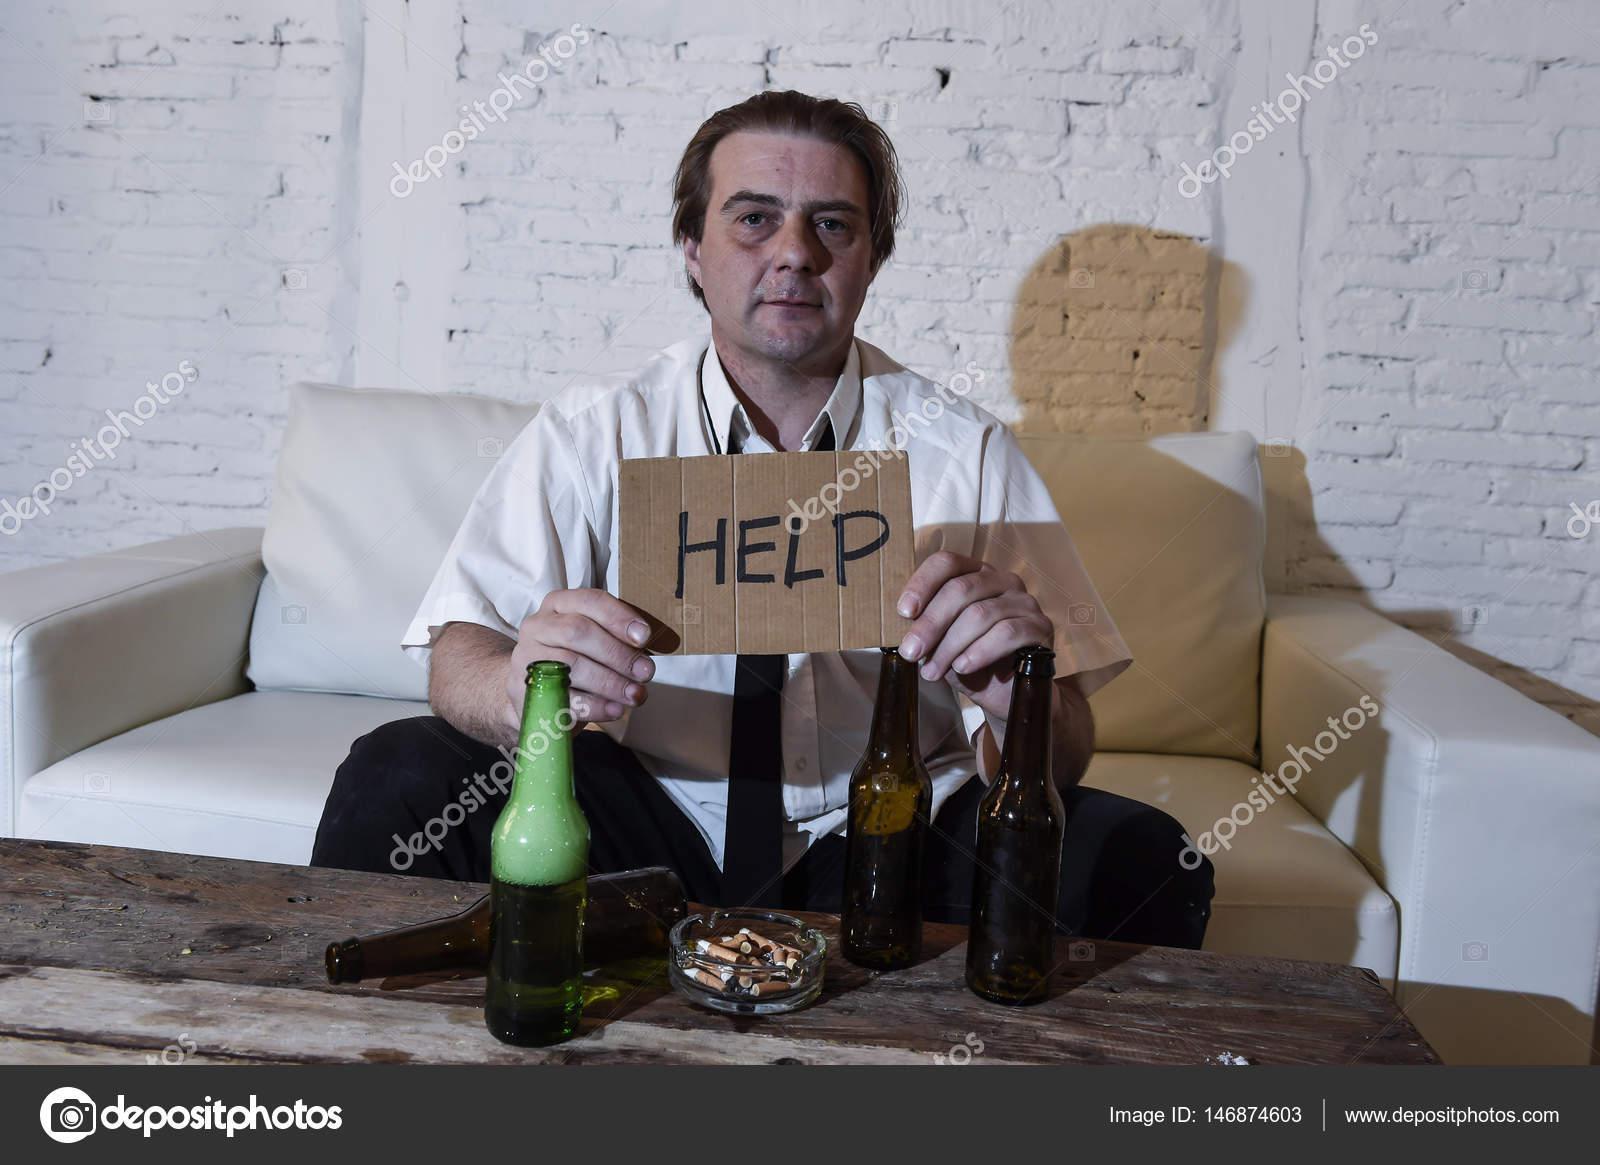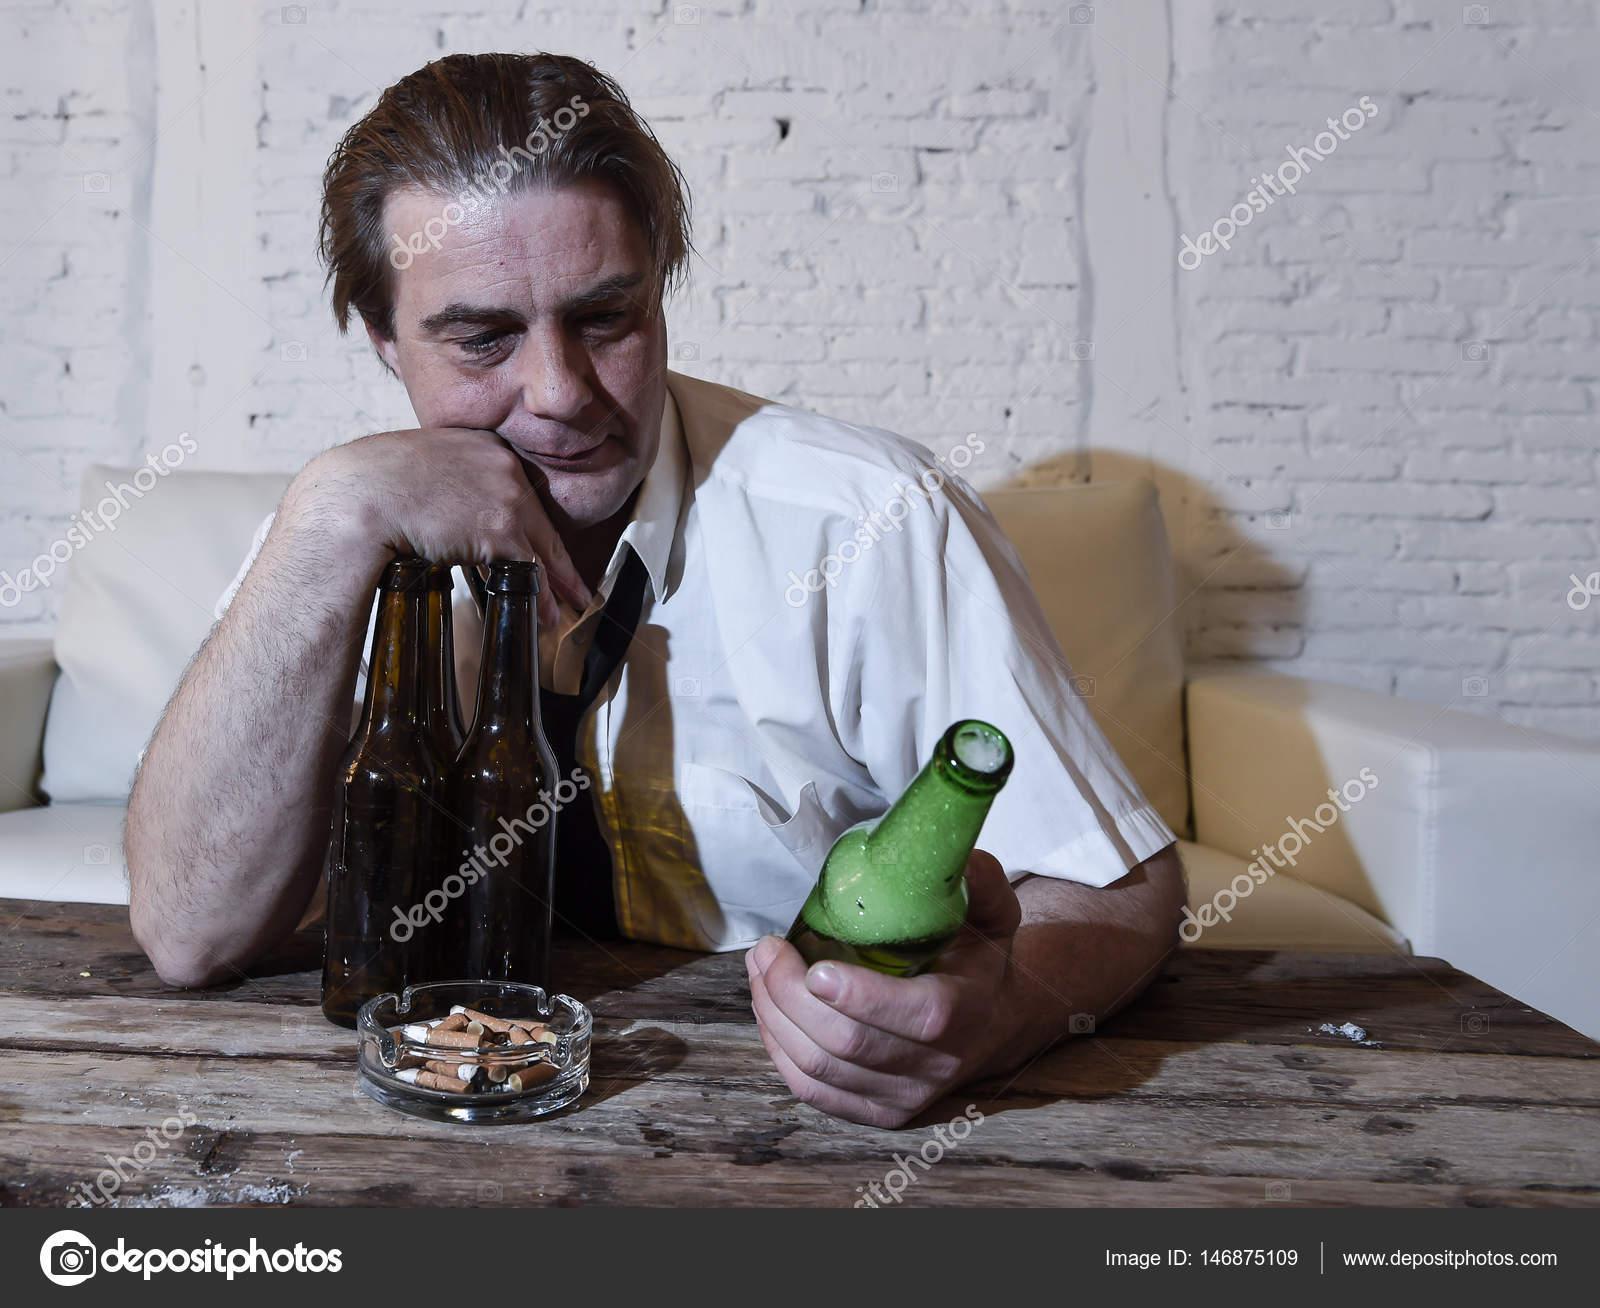The first image is the image on the left, the second image is the image on the right. Examine the images to the left and right. Is the description "A man is holding a bottle to his mouth." accurate? Answer yes or no. No. The first image is the image on the left, the second image is the image on the right. Analyze the images presented: Is the assertion "The man is drinking his beer in the left image." valid? Answer yes or no. No. 